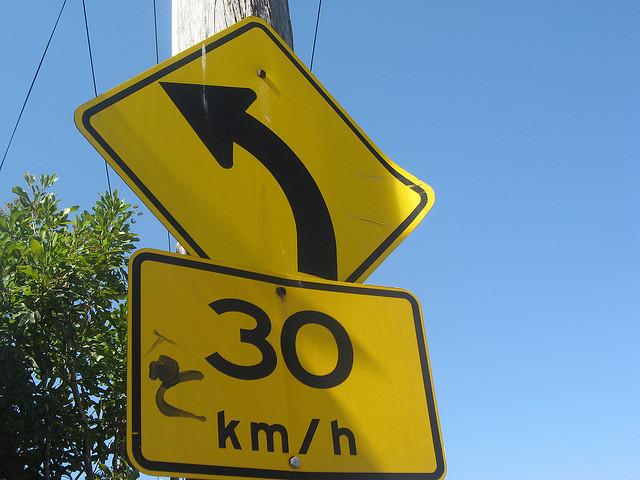Is this a residential neighborhood?
Answer briefly. Yes. What does the curved arrow mean?
Write a very short answer. Turn. Is it a crime to remove these signs?
Keep it brief. Yes. 